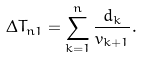Convert formula to latex. <formula><loc_0><loc_0><loc_500><loc_500>\Delta T _ { n 1 } = \sum _ { k = 1 } ^ { n } \frac { d _ { k } } { v _ { k + 1 } } .</formula> 